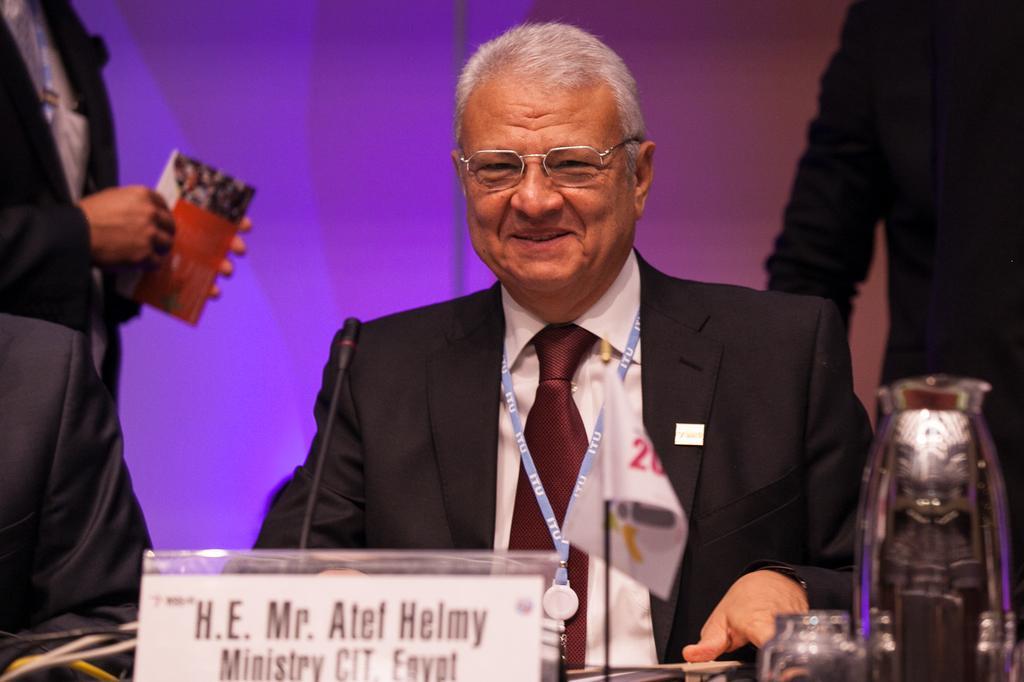How would you summarize this image in a sentence or two? This picture describes about few people, in the middle of the image we can see a man, he wore spectacles and he is smiling, in front of him we can find a microphone and other things. 